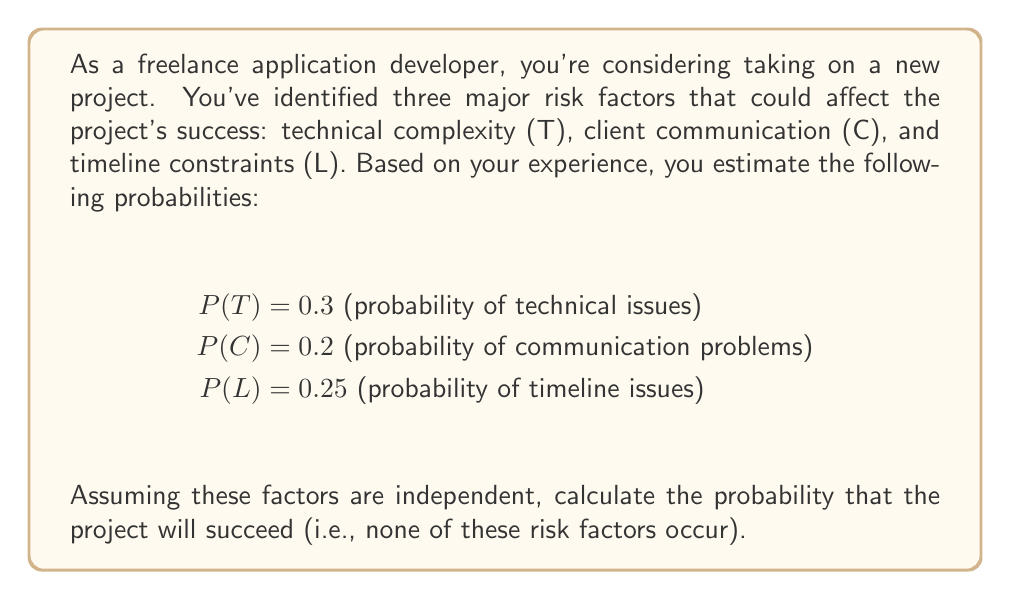Teach me how to tackle this problem. To solve this problem, we'll use the concept of independent events and the complement rule from probability theory.

1. First, let's define the success of the project as the absence of all risk factors. In other words, the project succeeds if neither technical issues, nor communication problems, nor timeline issues occur.

2. We can express this mathematically as:
   P(Success) = P(not T and not C and not L)

3. Since the events are independent, we can multiply the probabilities of their complements:
   P(Success) = P(not T) * P(not C) * P(not L)

4. The complement of an event A is given by P(not A) = 1 - P(A). Applying this to each risk factor:

   P(not T) = 1 - P(T) = 1 - 0.3 = 0.7
   P(not C) = 1 - P(C) = 1 - 0.2 = 0.8
   P(not L) = 1 - P(L) = 1 - 0.25 = 0.75

5. Now we can calculate the probability of success:

   $$P(\text{Success}) = 0.7 * 0.8 * 0.75$$

6. Multiplying these probabilities:

   $$P(\text{Success}) = 0.42$$

Therefore, the probability that the project will succeed, given these risk factors, is 0.42 or 42%.
Answer: The probability of project success is 0.42 or 42%. 